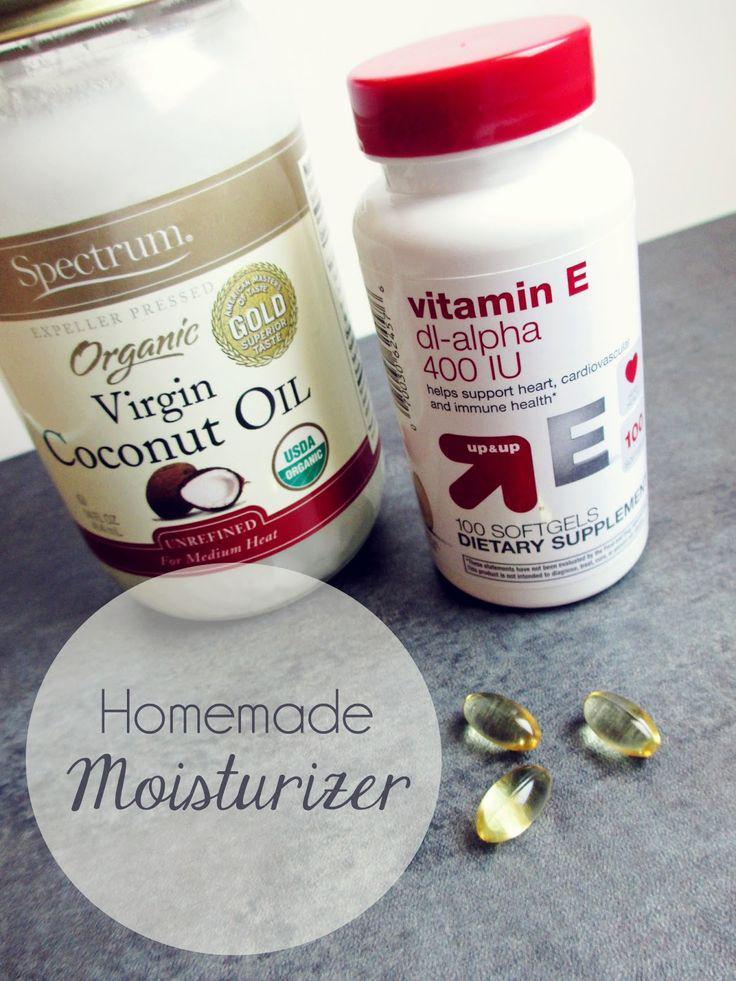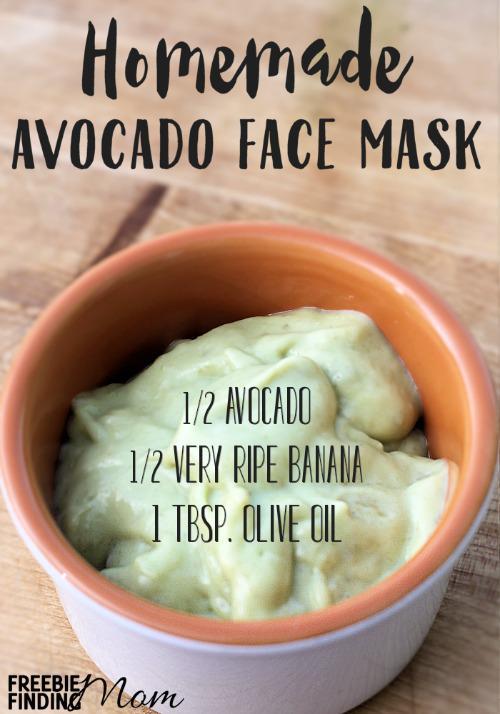The first image is the image on the left, the second image is the image on the right. For the images displayed, is the sentence "None of the creams are green." factually correct? Answer yes or no. No. The first image is the image on the left, the second image is the image on the right. Given the left and right images, does the statement "There are no spoons or spatulas in any of the images." hold true? Answer yes or no. Yes. 